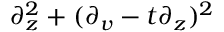Convert formula to latex. <formula><loc_0><loc_0><loc_500><loc_500>\partial _ { z } ^ { 2 } + ( \partial _ { v } - t \partial _ { z } ) ^ { 2 }</formula> 